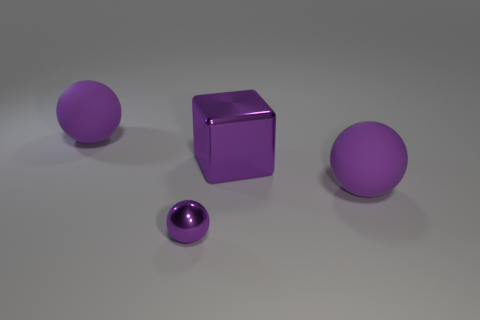The cube is what size?
Provide a succinct answer. Large. What number of brown things are big balls or big shiny objects?
Give a very brief answer. 0. There is a purple rubber ball that is in front of the matte sphere on the left side of the small shiny ball; what size is it?
Give a very brief answer. Large. Is the color of the big cube the same as the ball to the left of the tiny purple shiny ball?
Offer a terse response. Yes. How many other objects are the same material as the tiny purple sphere?
Offer a terse response. 1. The tiny purple object that is made of the same material as the large purple cube is what shape?
Your answer should be compact. Sphere. What size is the shiny ball that is the same color as the big metallic cube?
Provide a succinct answer. Small. Is the number of large purple objects on the right side of the purple shiny sphere greater than the number of large purple metallic objects?
Provide a short and direct response. Yes. Is the shape of the tiny metallic thing the same as the big purple object on the left side of the small purple thing?
Provide a succinct answer. Yes. What number of things have the same size as the metallic block?
Make the answer very short. 2. 